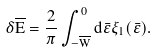<formula> <loc_0><loc_0><loc_500><loc_500>\delta \overline { E } = \frac { 2 } { \pi } \int _ { - \overline { W } } ^ { 0 } d \bar { \varepsilon } \xi _ { 1 } ( \bar { \varepsilon } ) .</formula> 